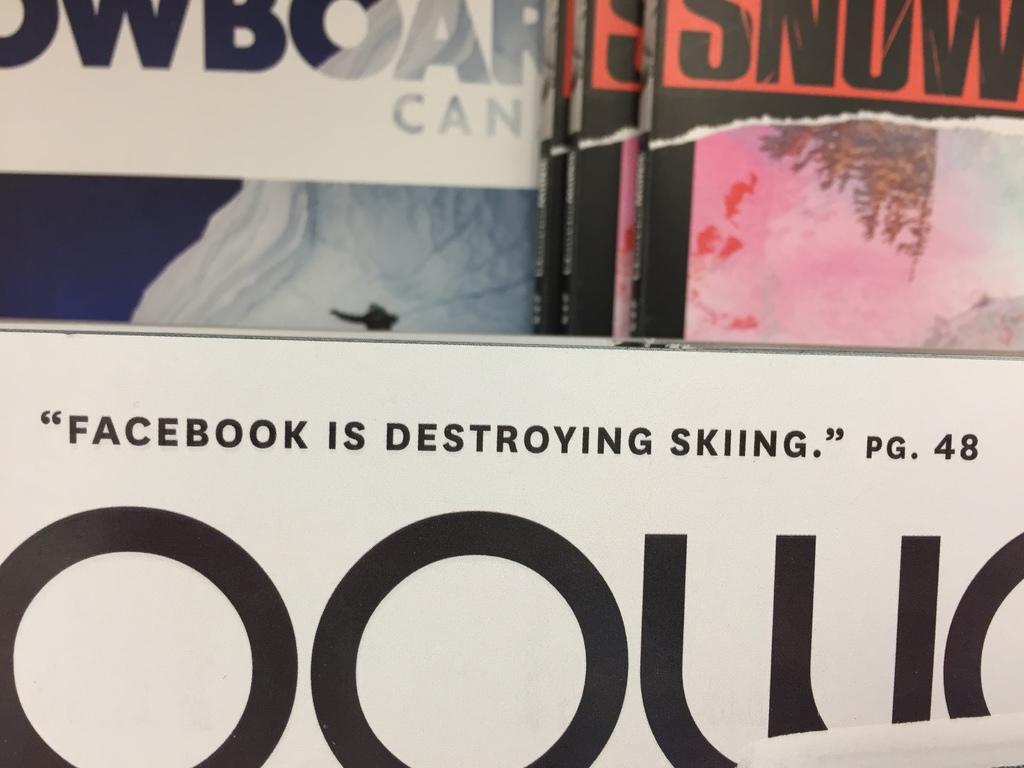<image>
Render a clear and concise summary of the photo. The poster suggests that Facebook can destroy skiing. 